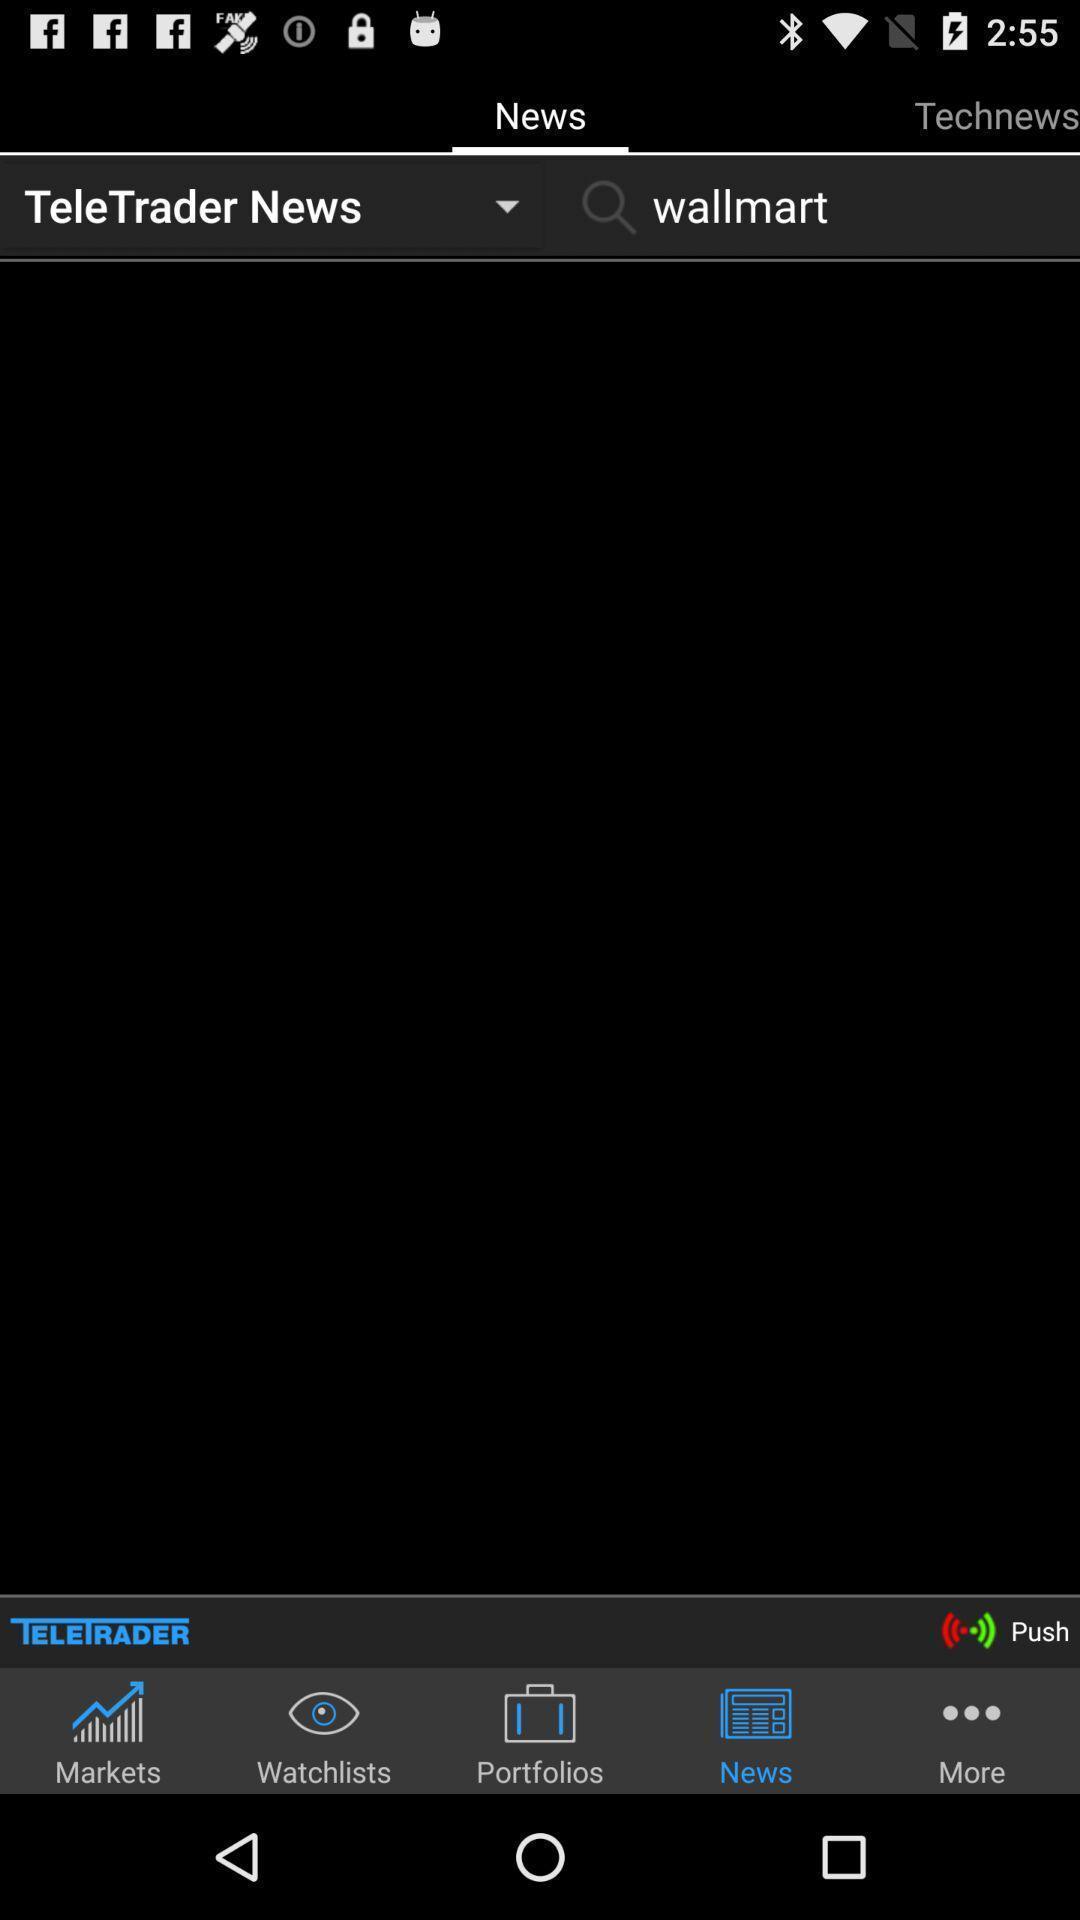Give me a narrative description of this picture. Page displaying various options in the app. 